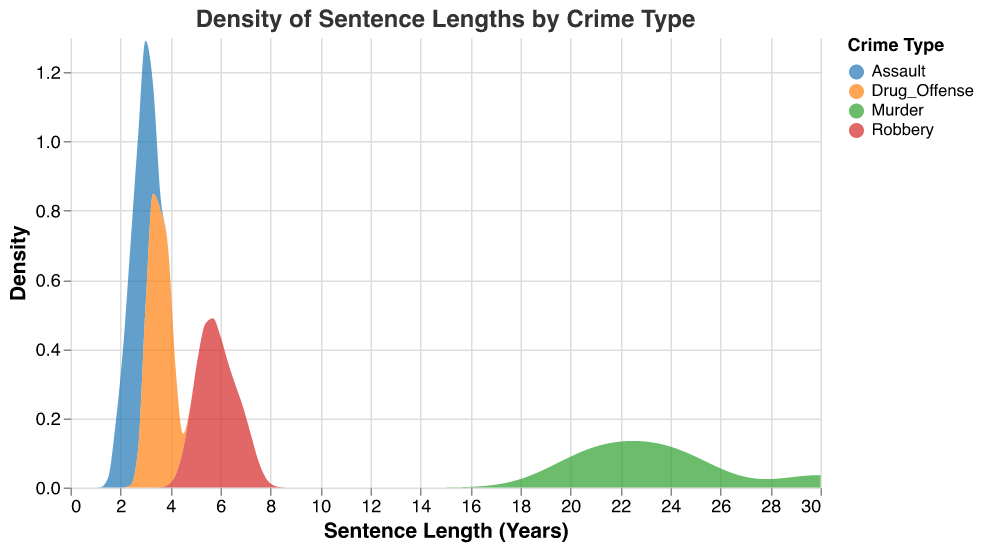what is the title of the plot? The title is the text that appears at the top of the figure. In this case, it provides an overview of what the figure represents.
Answer: Density of Sentence Lengths by Crime Type which crime type has the highest density at approximately 3 years of sentence length? To find this, we locate the 3-year mark on the x-axis and observe the density peaks of each crime type. The one with the highest peak around that mark is the answer.
Answer: drug offense which crime type has the widest range of sentence lengths? We observe the spread of the density curves along the x-axis. The crime type with the curve extending furthest both ways indicates the widest range.
Answer: murder how do the sentence lengths for robbery in california compare to those in new york? We can infer from the underlying data and observe the density plot. We compare the general locations and heights of the robbery density curves for both states around their respective sentence lengths.
Answer: California tends to have shorter average sentence lengths than New York which crime type shows less variability in sentence lengths? We look for the most concentrated density curve, indicating that most data points fall within a narrower range of sentence lengths.
Answer: assault what is the state with the highest sentence length for drug offenses? By referencing the data, we see the value corresponding to each state's drug offense sentence length.
Answer: New York which crime shows the highest peak density near 6 years? We examine the x-axis at the 6-year mark and compare the density levels of the different crime types. The highest peak around this area is our answer.
Answer: robbery what is the color scheme used to distinguish different crime types? The plot uses different color codes for four crime types. From visual inspection, identify the colors denoted by their names.
Answer: Blue, Orange, Green, Red 